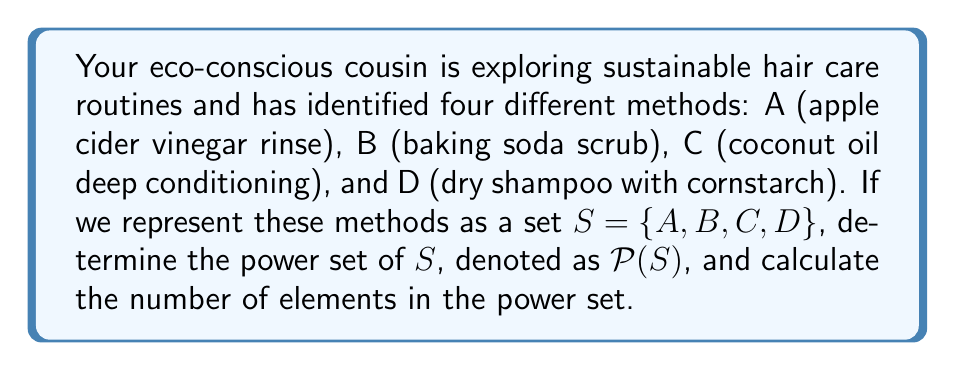Help me with this question. To solve this problem, we need to understand what a power set is and how to determine it:

1. The power set of a set $S$ is the set of all possible subsets of $S$, including the empty set $\emptyset$ and $S$ itself.

2. For a set with $n$ elements, the number of elements in its power set is $2^n$.

3. In this case, $S = \{A, B, C, D\}$ has 4 elements, so $n = 4$.

4. The number of elements in $\mathcal{P}(S)$ will be $2^4 = 16$.

5. To list all elements of $\mathcal{P}(S)$, we need to consider all possible combinations:

   - The empty set: $\emptyset$
   - Single-element subsets: $\{A\}$, $\{B\}$, $\{C\}$, $\{D\}$
   - Two-element subsets: $\{A,B\}$, $\{A,C\}$, $\{A,D\}$, $\{B,C\}$, $\{B,D\}$, $\{C,D\}$
   - Three-element subsets: $\{A,B,C\}$, $\{A,B,D\}$, $\{A,C,D\}$, $\{B,C,D\}$
   - The full set: $\{A,B,C,D\}$

Therefore, the power set $\mathcal{P}(S)$ contains all of these subsets.
Answer: $\mathcal{P}(S) = \{\emptyset, \{A\}, \{B\}, \{C\}, \{D\}, \{A,B\}, \{A,C\}, \{A,D\}, \{B,C\}, \{B,D\}, \{C,D\}, \{A,B,C\}, \{A,B,D\}, \{A,C,D\}, \{B,C,D\}, \{A,B,C,D\}\}$

The number of elements in $\mathcal{P}(S)$ is $16$. 